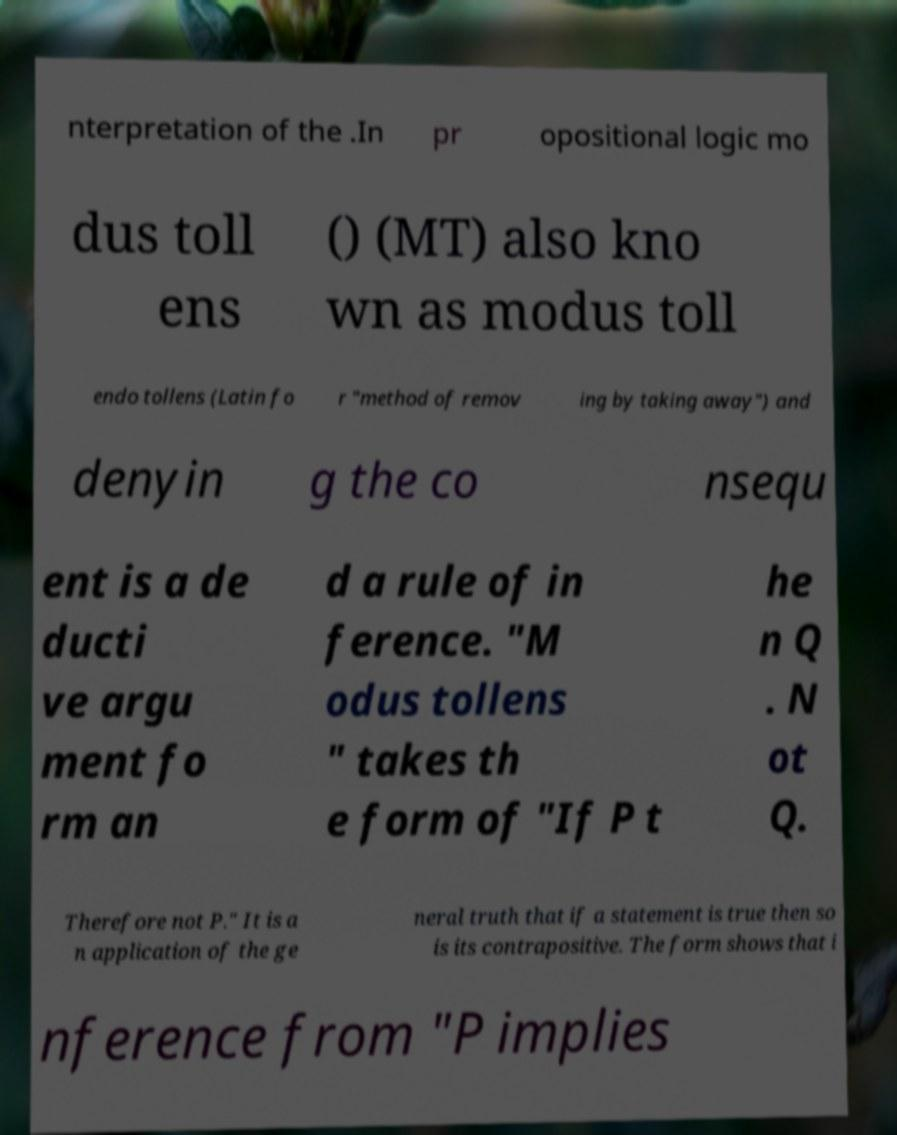Please identify and transcribe the text found in this image. nterpretation of the .In pr opositional logic mo dus toll ens () (MT) also kno wn as modus toll endo tollens (Latin fo r "method of remov ing by taking away") and denyin g the co nsequ ent is a de ducti ve argu ment fo rm an d a rule of in ference. "M odus tollens " takes th e form of "If P t he n Q . N ot Q. Therefore not P." It is a n application of the ge neral truth that if a statement is true then so is its contrapositive. The form shows that i nference from "P implies 